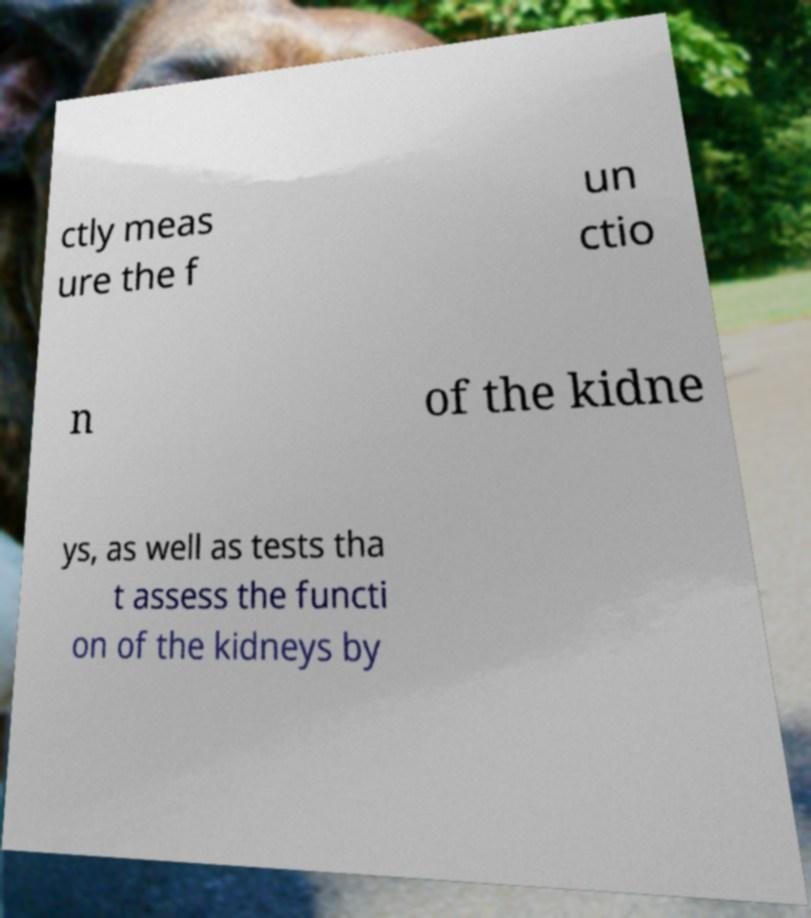What messages or text are displayed in this image? I need them in a readable, typed format. ctly meas ure the f un ctio n of the kidne ys, as well as tests tha t assess the functi on of the kidneys by 